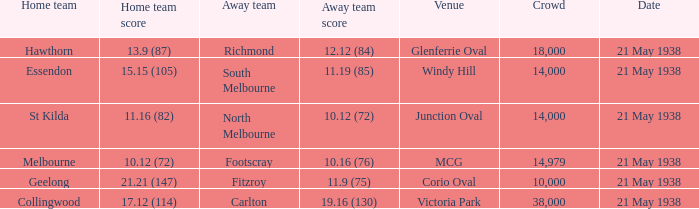Which away squad boasts a gathering exceeding 14,000 and a melbourne-based home team? Footscray. 